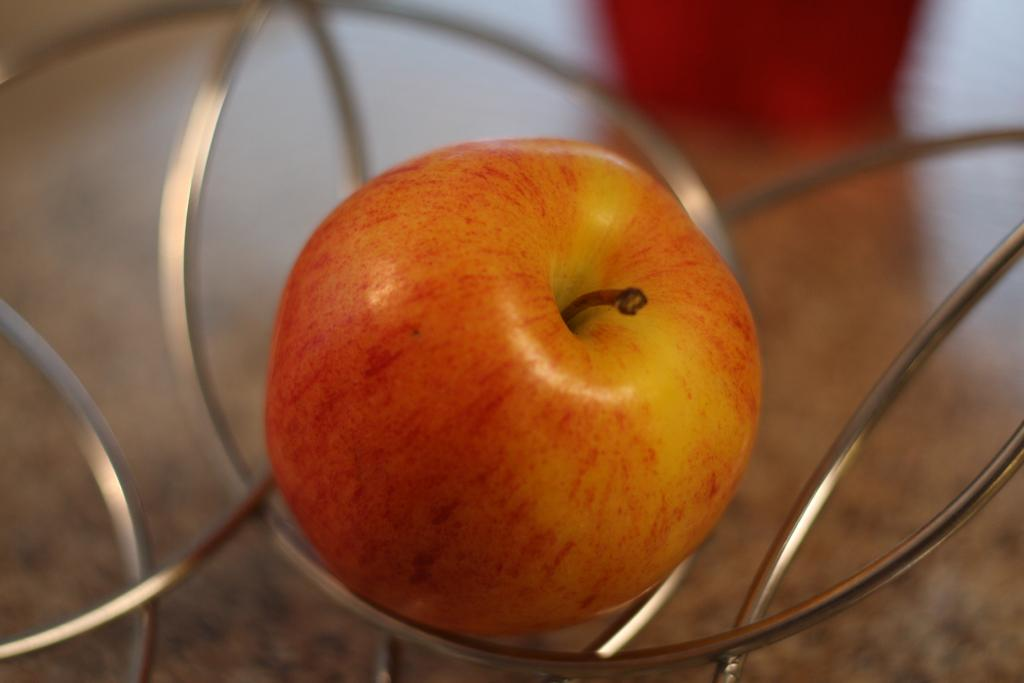What is the main object in the center of the image? There is a table in the center of the image. What is placed on the table? There is a basket on the table. What is inside the basket? There is an apple in the basket. What type of surprise is hidden under the flag in the image? There is no flag present in the image, so it is not possible to determine if there is a surprise hidden under it. 